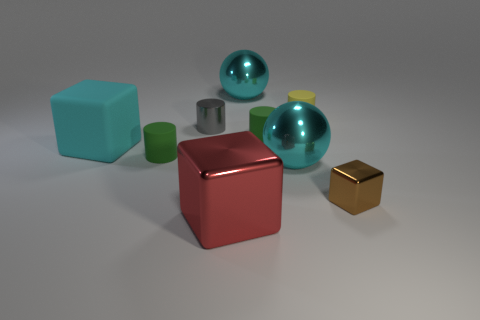There is a big cube that is behind the small shiny cube; what is its material?
Ensure brevity in your answer.  Rubber. What number of other things are there of the same shape as the gray object?
Keep it short and to the point. 3. Do the tiny yellow object and the gray metal thing have the same shape?
Your response must be concise. Yes. There is a tiny yellow thing; are there any tiny metallic cylinders behind it?
Your answer should be very brief. No. How many objects are either large cyan metal objects or big shiny blocks?
Provide a succinct answer. 3. How many other objects are there of the same size as the gray shiny thing?
Your response must be concise. 4. What number of cubes are both left of the red cube and to the right of the small yellow matte cylinder?
Provide a succinct answer. 0. Is the size of the matte cylinder that is in front of the rubber block the same as the cube that is behind the tiny brown block?
Ensure brevity in your answer.  No. What size is the shiny thing behind the yellow rubber object?
Your answer should be compact. Large. What number of things are small green rubber cylinders to the right of the red shiny thing or metal objects behind the brown block?
Keep it short and to the point. 4. 